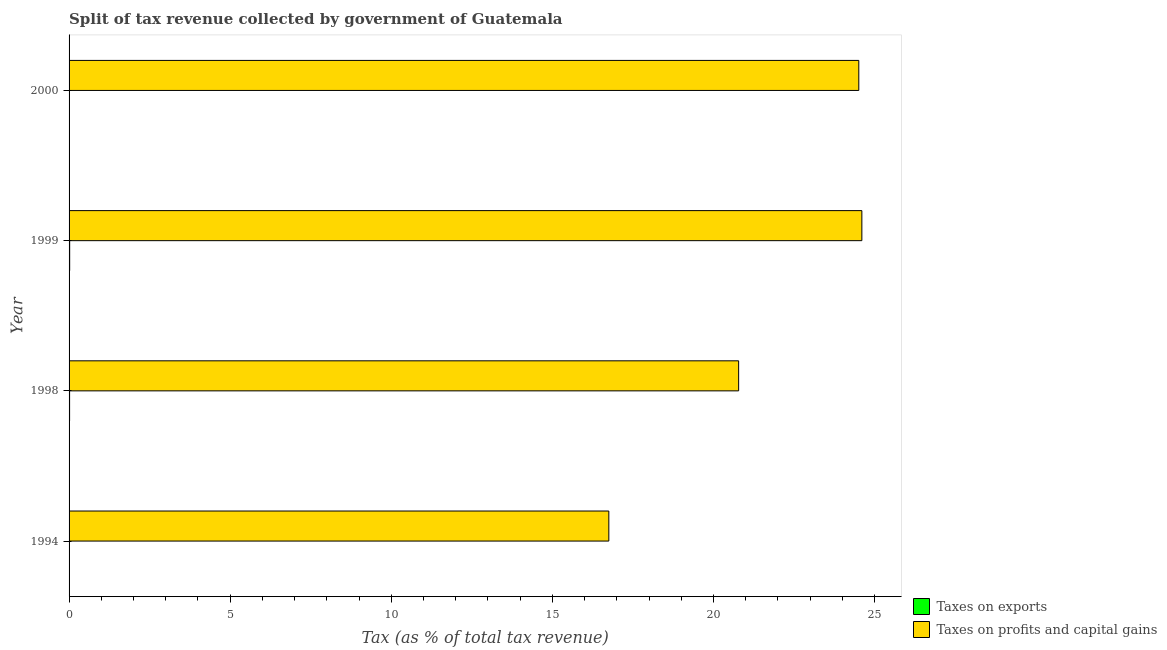How many groups of bars are there?
Provide a succinct answer. 4. Are the number of bars per tick equal to the number of legend labels?
Offer a terse response. Yes. Are the number of bars on each tick of the Y-axis equal?
Your answer should be compact. Yes. How many bars are there on the 3rd tick from the bottom?
Your answer should be very brief. 2. What is the label of the 2nd group of bars from the top?
Provide a succinct answer. 1999. In how many cases, is the number of bars for a given year not equal to the number of legend labels?
Give a very brief answer. 0. What is the percentage of revenue obtained from taxes on profits and capital gains in 1998?
Provide a succinct answer. 20.78. Across all years, what is the maximum percentage of revenue obtained from taxes on exports?
Ensure brevity in your answer.  0.02. Across all years, what is the minimum percentage of revenue obtained from taxes on exports?
Keep it short and to the point. 0. In which year was the percentage of revenue obtained from taxes on profits and capital gains maximum?
Your answer should be compact. 1999. What is the total percentage of revenue obtained from taxes on profits and capital gains in the graph?
Provide a succinct answer. 86.64. What is the difference between the percentage of revenue obtained from taxes on exports in 1999 and that in 2000?
Give a very brief answer. 0.01. What is the difference between the percentage of revenue obtained from taxes on profits and capital gains in 2000 and the percentage of revenue obtained from taxes on exports in 1998?
Your response must be concise. 24.49. What is the average percentage of revenue obtained from taxes on profits and capital gains per year?
Provide a short and direct response. 21.66. In the year 2000, what is the difference between the percentage of revenue obtained from taxes on profits and capital gains and percentage of revenue obtained from taxes on exports?
Offer a terse response. 24.5. In how many years, is the percentage of revenue obtained from taxes on exports greater than 24 %?
Give a very brief answer. 0. What is the ratio of the percentage of revenue obtained from taxes on profits and capital gains in 1994 to that in 1999?
Give a very brief answer. 0.68. Is the percentage of revenue obtained from taxes on exports in 1998 less than that in 1999?
Offer a terse response. Yes. Is the difference between the percentage of revenue obtained from taxes on exports in 1998 and 2000 greater than the difference between the percentage of revenue obtained from taxes on profits and capital gains in 1998 and 2000?
Your answer should be very brief. Yes. What is the difference between the highest and the second highest percentage of revenue obtained from taxes on profits and capital gains?
Offer a very short reply. 0.1. In how many years, is the percentage of revenue obtained from taxes on profits and capital gains greater than the average percentage of revenue obtained from taxes on profits and capital gains taken over all years?
Offer a terse response. 2. Is the sum of the percentage of revenue obtained from taxes on exports in 1994 and 1998 greater than the maximum percentage of revenue obtained from taxes on profits and capital gains across all years?
Your answer should be very brief. No. What does the 2nd bar from the top in 2000 represents?
Provide a succinct answer. Taxes on exports. What does the 2nd bar from the bottom in 1998 represents?
Offer a terse response. Taxes on profits and capital gains. What is the title of the graph?
Provide a short and direct response. Split of tax revenue collected by government of Guatemala. Does "Merchandise imports" appear as one of the legend labels in the graph?
Provide a succinct answer. No. What is the label or title of the X-axis?
Give a very brief answer. Tax (as % of total tax revenue). What is the label or title of the Y-axis?
Ensure brevity in your answer.  Year. What is the Tax (as % of total tax revenue) in Taxes on exports in 1994?
Your answer should be compact. 0. What is the Tax (as % of total tax revenue) of Taxes on profits and capital gains in 1994?
Provide a succinct answer. 16.75. What is the Tax (as % of total tax revenue) of Taxes on exports in 1998?
Your answer should be very brief. 0.02. What is the Tax (as % of total tax revenue) in Taxes on profits and capital gains in 1998?
Your answer should be compact. 20.78. What is the Tax (as % of total tax revenue) in Taxes on exports in 1999?
Your answer should be very brief. 0.02. What is the Tax (as % of total tax revenue) of Taxes on profits and capital gains in 1999?
Ensure brevity in your answer.  24.6. What is the Tax (as % of total tax revenue) in Taxes on exports in 2000?
Your response must be concise. 0.01. What is the Tax (as % of total tax revenue) in Taxes on profits and capital gains in 2000?
Ensure brevity in your answer.  24.51. Across all years, what is the maximum Tax (as % of total tax revenue) of Taxes on exports?
Give a very brief answer. 0.02. Across all years, what is the maximum Tax (as % of total tax revenue) in Taxes on profits and capital gains?
Offer a very short reply. 24.6. Across all years, what is the minimum Tax (as % of total tax revenue) of Taxes on exports?
Make the answer very short. 0. Across all years, what is the minimum Tax (as % of total tax revenue) of Taxes on profits and capital gains?
Offer a very short reply. 16.75. What is the total Tax (as % of total tax revenue) in Taxes on exports in the graph?
Give a very brief answer. 0.05. What is the total Tax (as % of total tax revenue) of Taxes on profits and capital gains in the graph?
Offer a terse response. 86.64. What is the difference between the Tax (as % of total tax revenue) of Taxes on exports in 1994 and that in 1998?
Your response must be concise. -0.02. What is the difference between the Tax (as % of total tax revenue) of Taxes on profits and capital gains in 1994 and that in 1998?
Ensure brevity in your answer.  -4.03. What is the difference between the Tax (as % of total tax revenue) of Taxes on exports in 1994 and that in 1999?
Provide a succinct answer. -0.02. What is the difference between the Tax (as % of total tax revenue) in Taxes on profits and capital gains in 1994 and that in 1999?
Give a very brief answer. -7.85. What is the difference between the Tax (as % of total tax revenue) of Taxes on exports in 1994 and that in 2000?
Offer a very short reply. -0.01. What is the difference between the Tax (as % of total tax revenue) in Taxes on profits and capital gains in 1994 and that in 2000?
Keep it short and to the point. -7.76. What is the difference between the Tax (as % of total tax revenue) of Taxes on exports in 1998 and that in 1999?
Offer a very short reply. -0. What is the difference between the Tax (as % of total tax revenue) of Taxes on profits and capital gains in 1998 and that in 1999?
Give a very brief answer. -3.82. What is the difference between the Tax (as % of total tax revenue) in Taxes on exports in 1998 and that in 2000?
Your answer should be compact. 0.01. What is the difference between the Tax (as % of total tax revenue) of Taxes on profits and capital gains in 1998 and that in 2000?
Offer a very short reply. -3.73. What is the difference between the Tax (as % of total tax revenue) in Taxes on exports in 1999 and that in 2000?
Make the answer very short. 0.01. What is the difference between the Tax (as % of total tax revenue) of Taxes on profits and capital gains in 1999 and that in 2000?
Your answer should be compact. 0.09. What is the difference between the Tax (as % of total tax revenue) in Taxes on exports in 1994 and the Tax (as % of total tax revenue) in Taxes on profits and capital gains in 1998?
Offer a terse response. -20.78. What is the difference between the Tax (as % of total tax revenue) of Taxes on exports in 1994 and the Tax (as % of total tax revenue) of Taxes on profits and capital gains in 1999?
Provide a succinct answer. -24.6. What is the difference between the Tax (as % of total tax revenue) of Taxes on exports in 1994 and the Tax (as % of total tax revenue) of Taxes on profits and capital gains in 2000?
Your answer should be very brief. -24.51. What is the difference between the Tax (as % of total tax revenue) in Taxes on exports in 1998 and the Tax (as % of total tax revenue) in Taxes on profits and capital gains in 1999?
Give a very brief answer. -24.59. What is the difference between the Tax (as % of total tax revenue) of Taxes on exports in 1998 and the Tax (as % of total tax revenue) of Taxes on profits and capital gains in 2000?
Give a very brief answer. -24.49. What is the difference between the Tax (as % of total tax revenue) in Taxes on exports in 1999 and the Tax (as % of total tax revenue) in Taxes on profits and capital gains in 2000?
Offer a very short reply. -24.49. What is the average Tax (as % of total tax revenue) of Taxes on exports per year?
Provide a succinct answer. 0.01. What is the average Tax (as % of total tax revenue) of Taxes on profits and capital gains per year?
Keep it short and to the point. 21.66. In the year 1994, what is the difference between the Tax (as % of total tax revenue) in Taxes on exports and Tax (as % of total tax revenue) in Taxes on profits and capital gains?
Your response must be concise. -16.75. In the year 1998, what is the difference between the Tax (as % of total tax revenue) of Taxes on exports and Tax (as % of total tax revenue) of Taxes on profits and capital gains?
Keep it short and to the point. -20.76. In the year 1999, what is the difference between the Tax (as % of total tax revenue) in Taxes on exports and Tax (as % of total tax revenue) in Taxes on profits and capital gains?
Keep it short and to the point. -24.58. In the year 2000, what is the difference between the Tax (as % of total tax revenue) in Taxes on exports and Tax (as % of total tax revenue) in Taxes on profits and capital gains?
Keep it short and to the point. -24.5. What is the ratio of the Tax (as % of total tax revenue) in Taxes on exports in 1994 to that in 1998?
Keep it short and to the point. 0.01. What is the ratio of the Tax (as % of total tax revenue) in Taxes on profits and capital gains in 1994 to that in 1998?
Your response must be concise. 0.81. What is the ratio of the Tax (as % of total tax revenue) of Taxes on exports in 1994 to that in 1999?
Your answer should be compact. 0.01. What is the ratio of the Tax (as % of total tax revenue) of Taxes on profits and capital gains in 1994 to that in 1999?
Give a very brief answer. 0.68. What is the ratio of the Tax (as % of total tax revenue) of Taxes on exports in 1994 to that in 2000?
Offer a very short reply. 0.02. What is the ratio of the Tax (as % of total tax revenue) in Taxes on profits and capital gains in 1994 to that in 2000?
Keep it short and to the point. 0.68. What is the ratio of the Tax (as % of total tax revenue) in Taxes on exports in 1998 to that in 1999?
Your answer should be very brief. 0.87. What is the ratio of the Tax (as % of total tax revenue) of Taxes on profits and capital gains in 1998 to that in 1999?
Provide a short and direct response. 0.84. What is the ratio of the Tax (as % of total tax revenue) of Taxes on exports in 1998 to that in 2000?
Provide a short and direct response. 1.66. What is the ratio of the Tax (as % of total tax revenue) of Taxes on profits and capital gains in 1998 to that in 2000?
Your answer should be compact. 0.85. What is the ratio of the Tax (as % of total tax revenue) in Taxes on exports in 1999 to that in 2000?
Your answer should be very brief. 1.9. What is the difference between the highest and the second highest Tax (as % of total tax revenue) in Taxes on exports?
Keep it short and to the point. 0. What is the difference between the highest and the second highest Tax (as % of total tax revenue) of Taxes on profits and capital gains?
Offer a very short reply. 0.09. What is the difference between the highest and the lowest Tax (as % of total tax revenue) of Taxes on exports?
Provide a succinct answer. 0.02. What is the difference between the highest and the lowest Tax (as % of total tax revenue) in Taxes on profits and capital gains?
Your response must be concise. 7.85. 